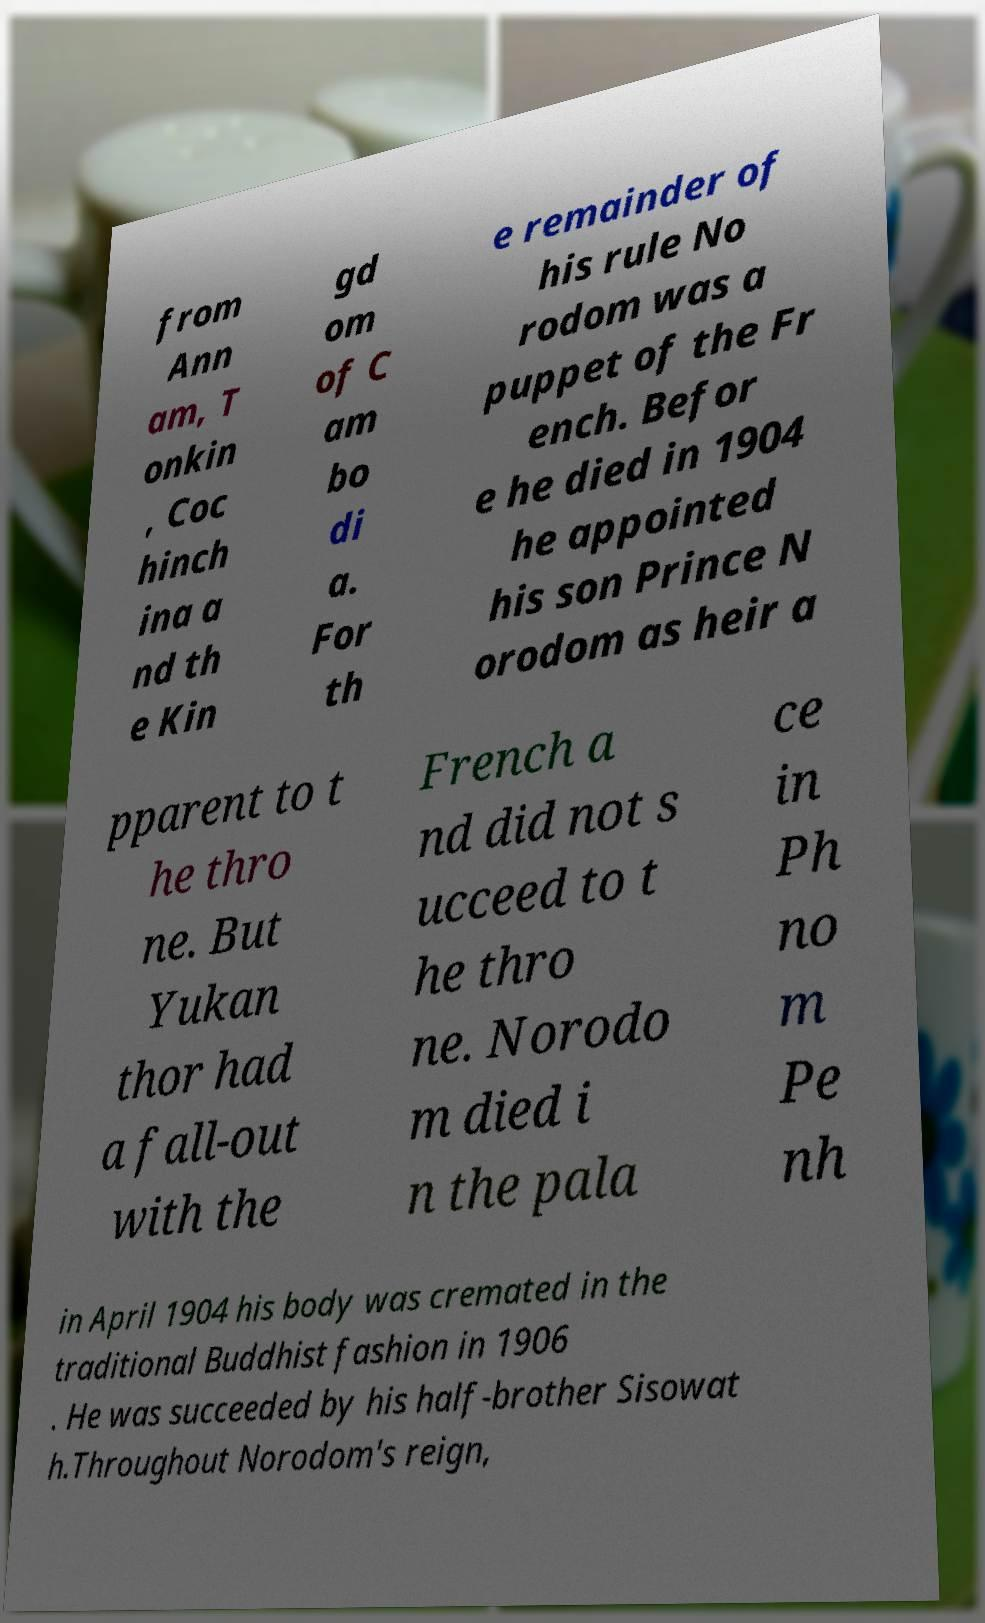What messages or text are displayed in this image? I need them in a readable, typed format. from Ann am, T onkin , Coc hinch ina a nd th e Kin gd om of C am bo di a. For th e remainder of his rule No rodom was a puppet of the Fr ench. Befor e he died in 1904 he appointed his son Prince N orodom as heir a pparent to t he thro ne. But Yukan thor had a fall-out with the French a nd did not s ucceed to t he thro ne. Norodo m died i n the pala ce in Ph no m Pe nh in April 1904 his body was cremated in the traditional Buddhist fashion in 1906 . He was succeeded by his half-brother Sisowat h.Throughout Norodom's reign, 